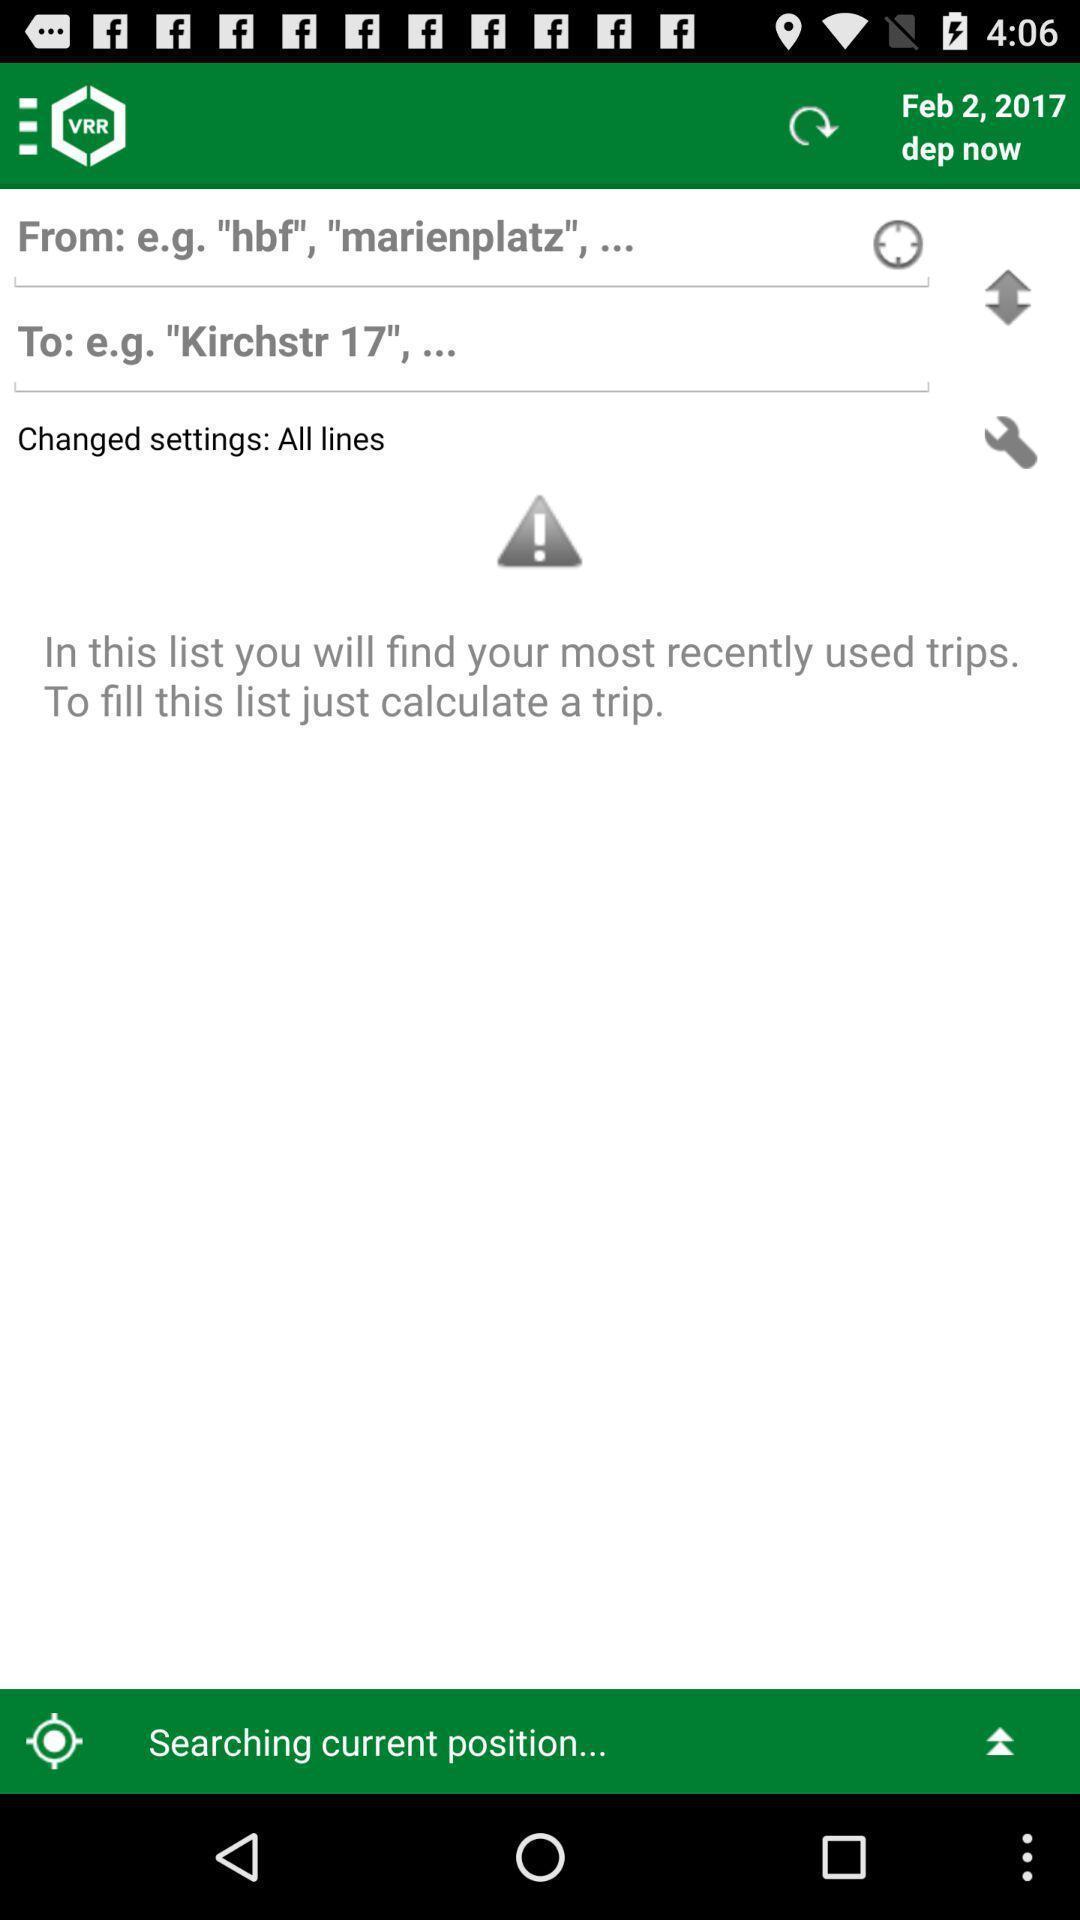What can you discern from this picture? Various navigation options available in the app. 